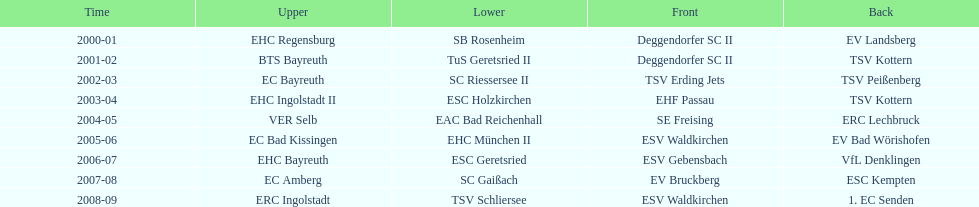How many champions are listend in the north? 9. 